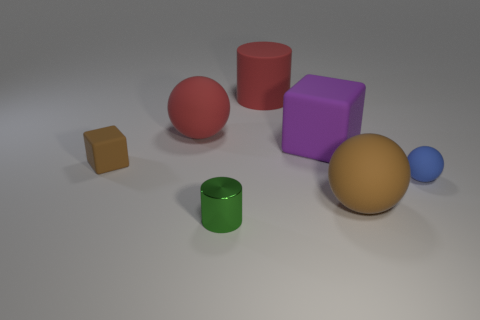Can you describe the shapes and colors present in the image? Certainly! The image features a variety of geometric shapes in different colors. There's a small orange cube, a large red cylinder, a medium-sized tan sphere, a blue sphere which is the smallest object, a medium-sized purple cube, and a green cylinder of medium size. Which object stands out the most to you? The red cylinder stands out due to its vibrant color and its height compared to the other objects. It draws attention amidst the range of shapes and sizes. 